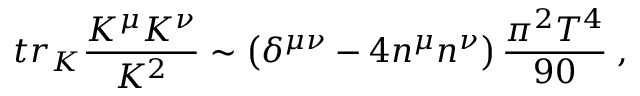Convert formula to latex. <formula><loc_0><loc_0><loc_500><loc_500>t r _ { K } \frac { K ^ { \mu } K ^ { \nu } } { K ^ { 2 } } \sim \left ( \delta ^ { \mu \nu } - 4 n ^ { \mu } n ^ { \nu } \right ) \frac { \pi ^ { 2 } T ^ { 4 } } { 9 0 } \, ,</formula> 